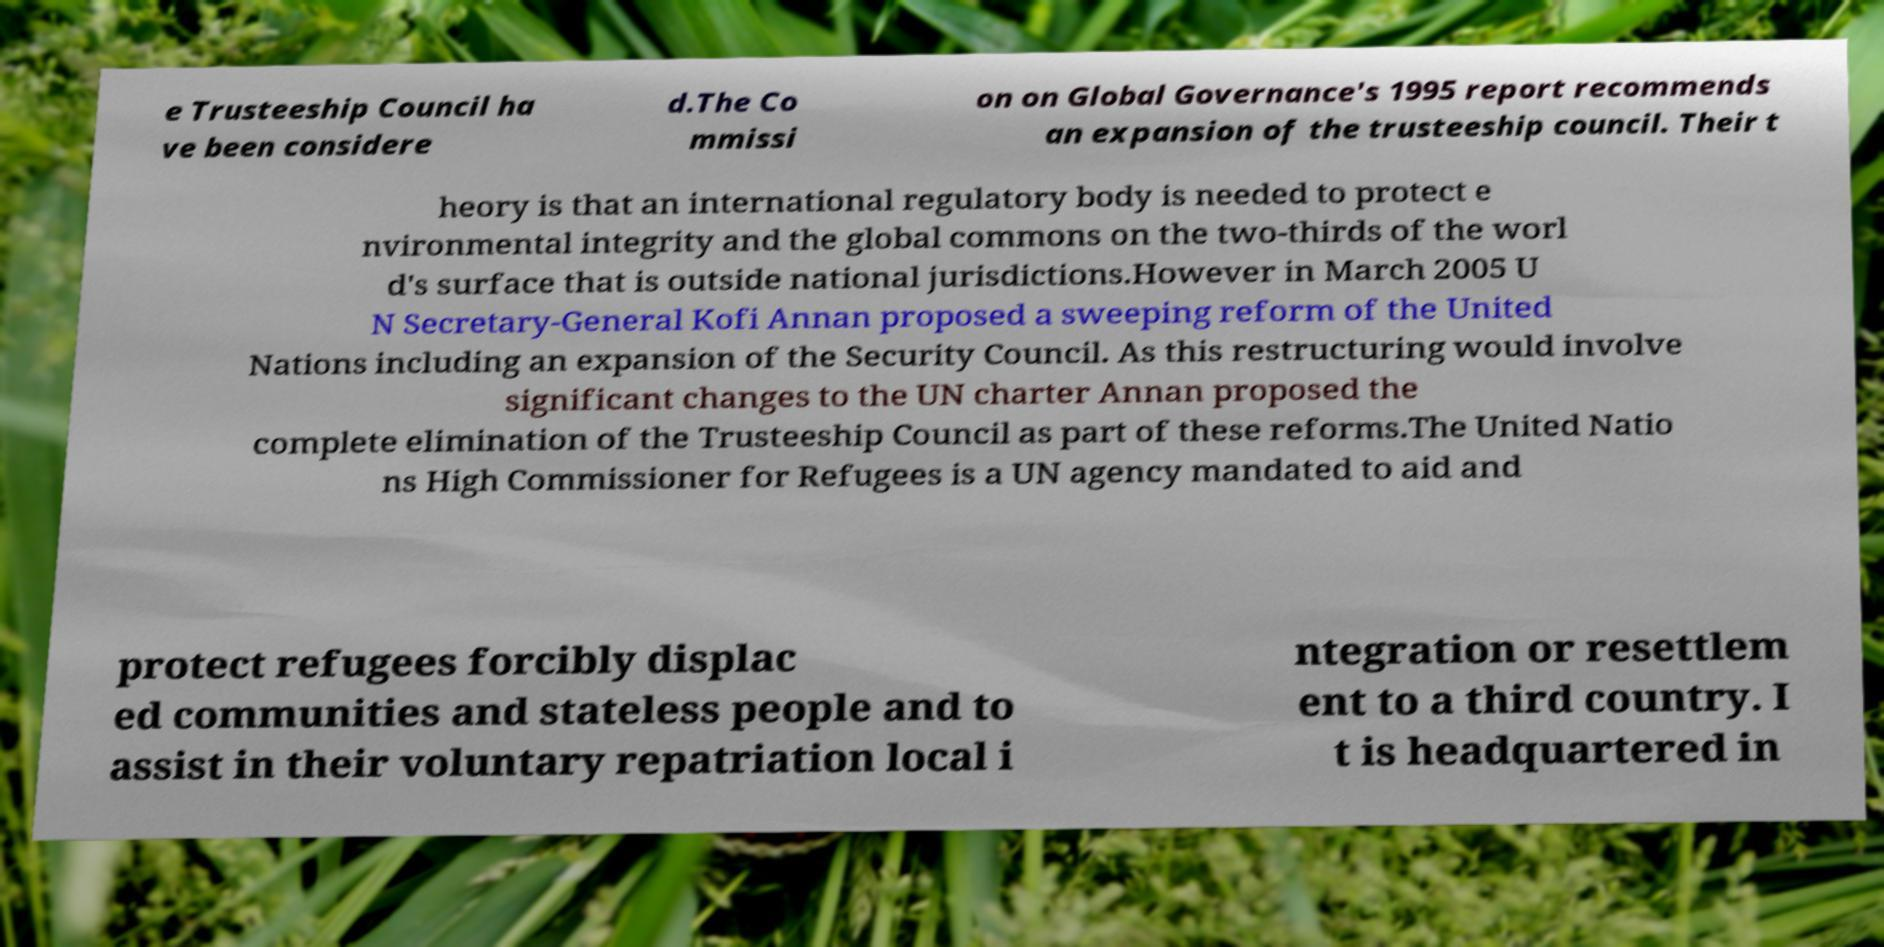There's text embedded in this image that I need extracted. Can you transcribe it verbatim? e Trusteeship Council ha ve been considere d.The Co mmissi on on Global Governance's 1995 report recommends an expansion of the trusteeship council. Their t heory is that an international regulatory body is needed to protect e nvironmental integrity and the global commons on the two-thirds of the worl d's surface that is outside national jurisdictions.However in March 2005 U N Secretary-General Kofi Annan proposed a sweeping reform of the United Nations including an expansion of the Security Council. As this restructuring would involve significant changes to the UN charter Annan proposed the complete elimination of the Trusteeship Council as part of these reforms.The United Natio ns High Commissioner for Refugees is a UN agency mandated to aid and protect refugees forcibly displac ed communities and stateless people and to assist in their voluntary repatriation local i ntegration or resettlem ent to a third country. I t is headquartered in 